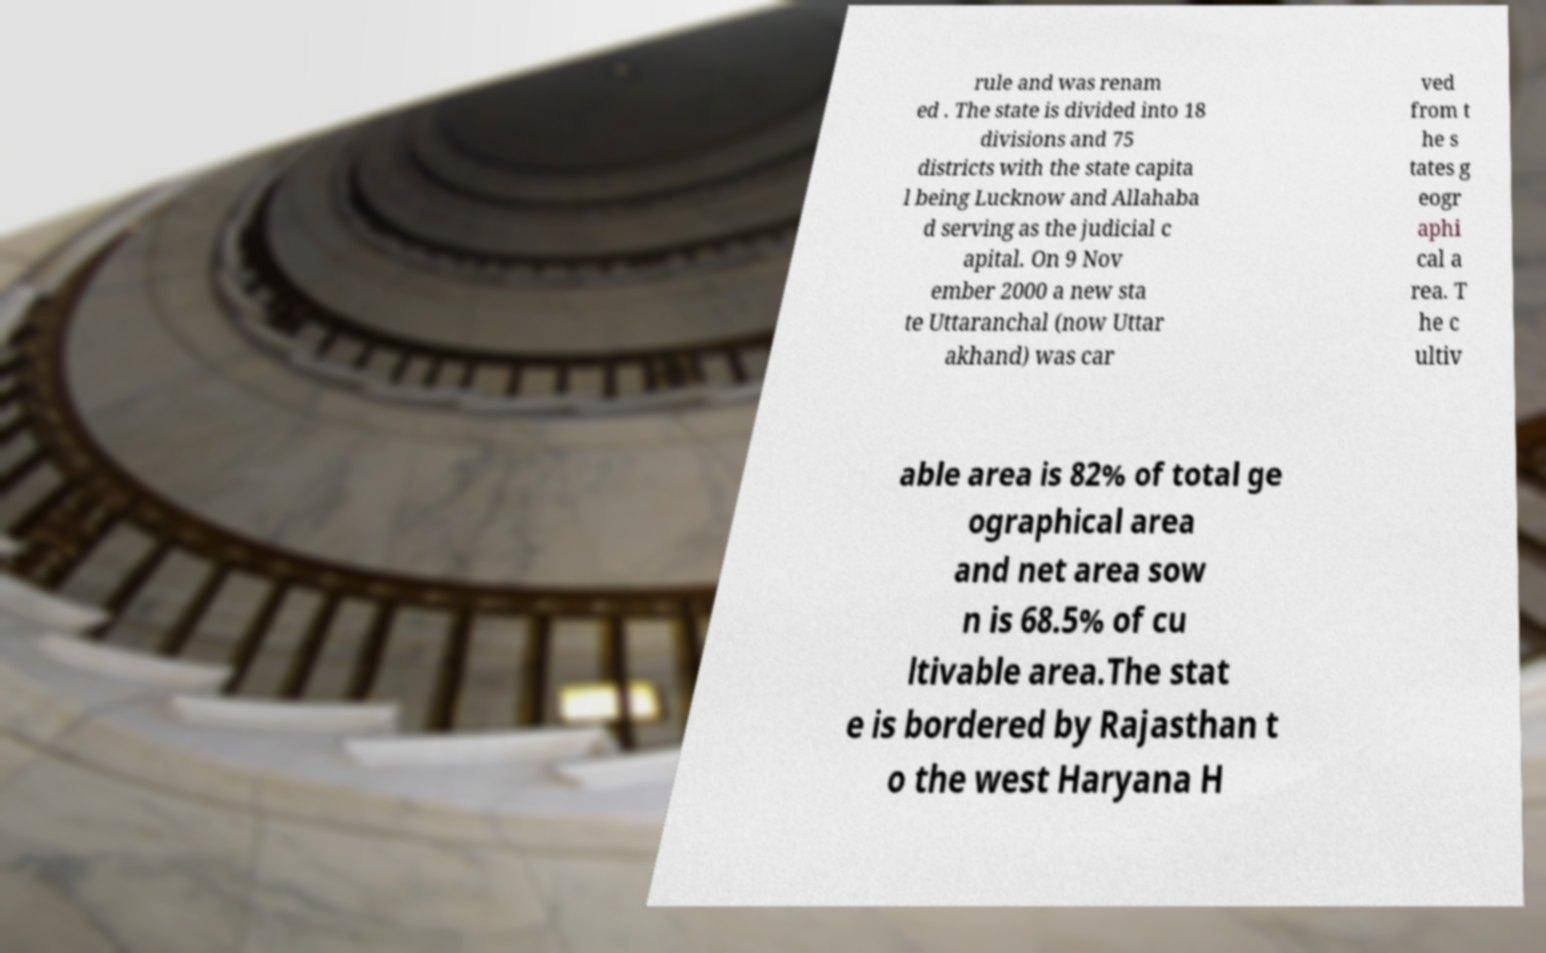There's text embedded in this image that I need extracted. Can you transcribe it verbatim? rule and was renam ed . The state is divided into 18 divisions and 75 districts with the state capita l being Lucknow and Allahaba d serving as the judicial c apital. On 9 Nov ember 2000 a new sta te Uttaranchal (now Uttar akhand) was car ved from t he s tates g eogr aphi cal a rea. T he c ultiv able area is 82% of total ge ographical area and net area sow n is 68.5% of cu ltivable area.The stat e is bordered by Rajasthan t o the west Haryana H 